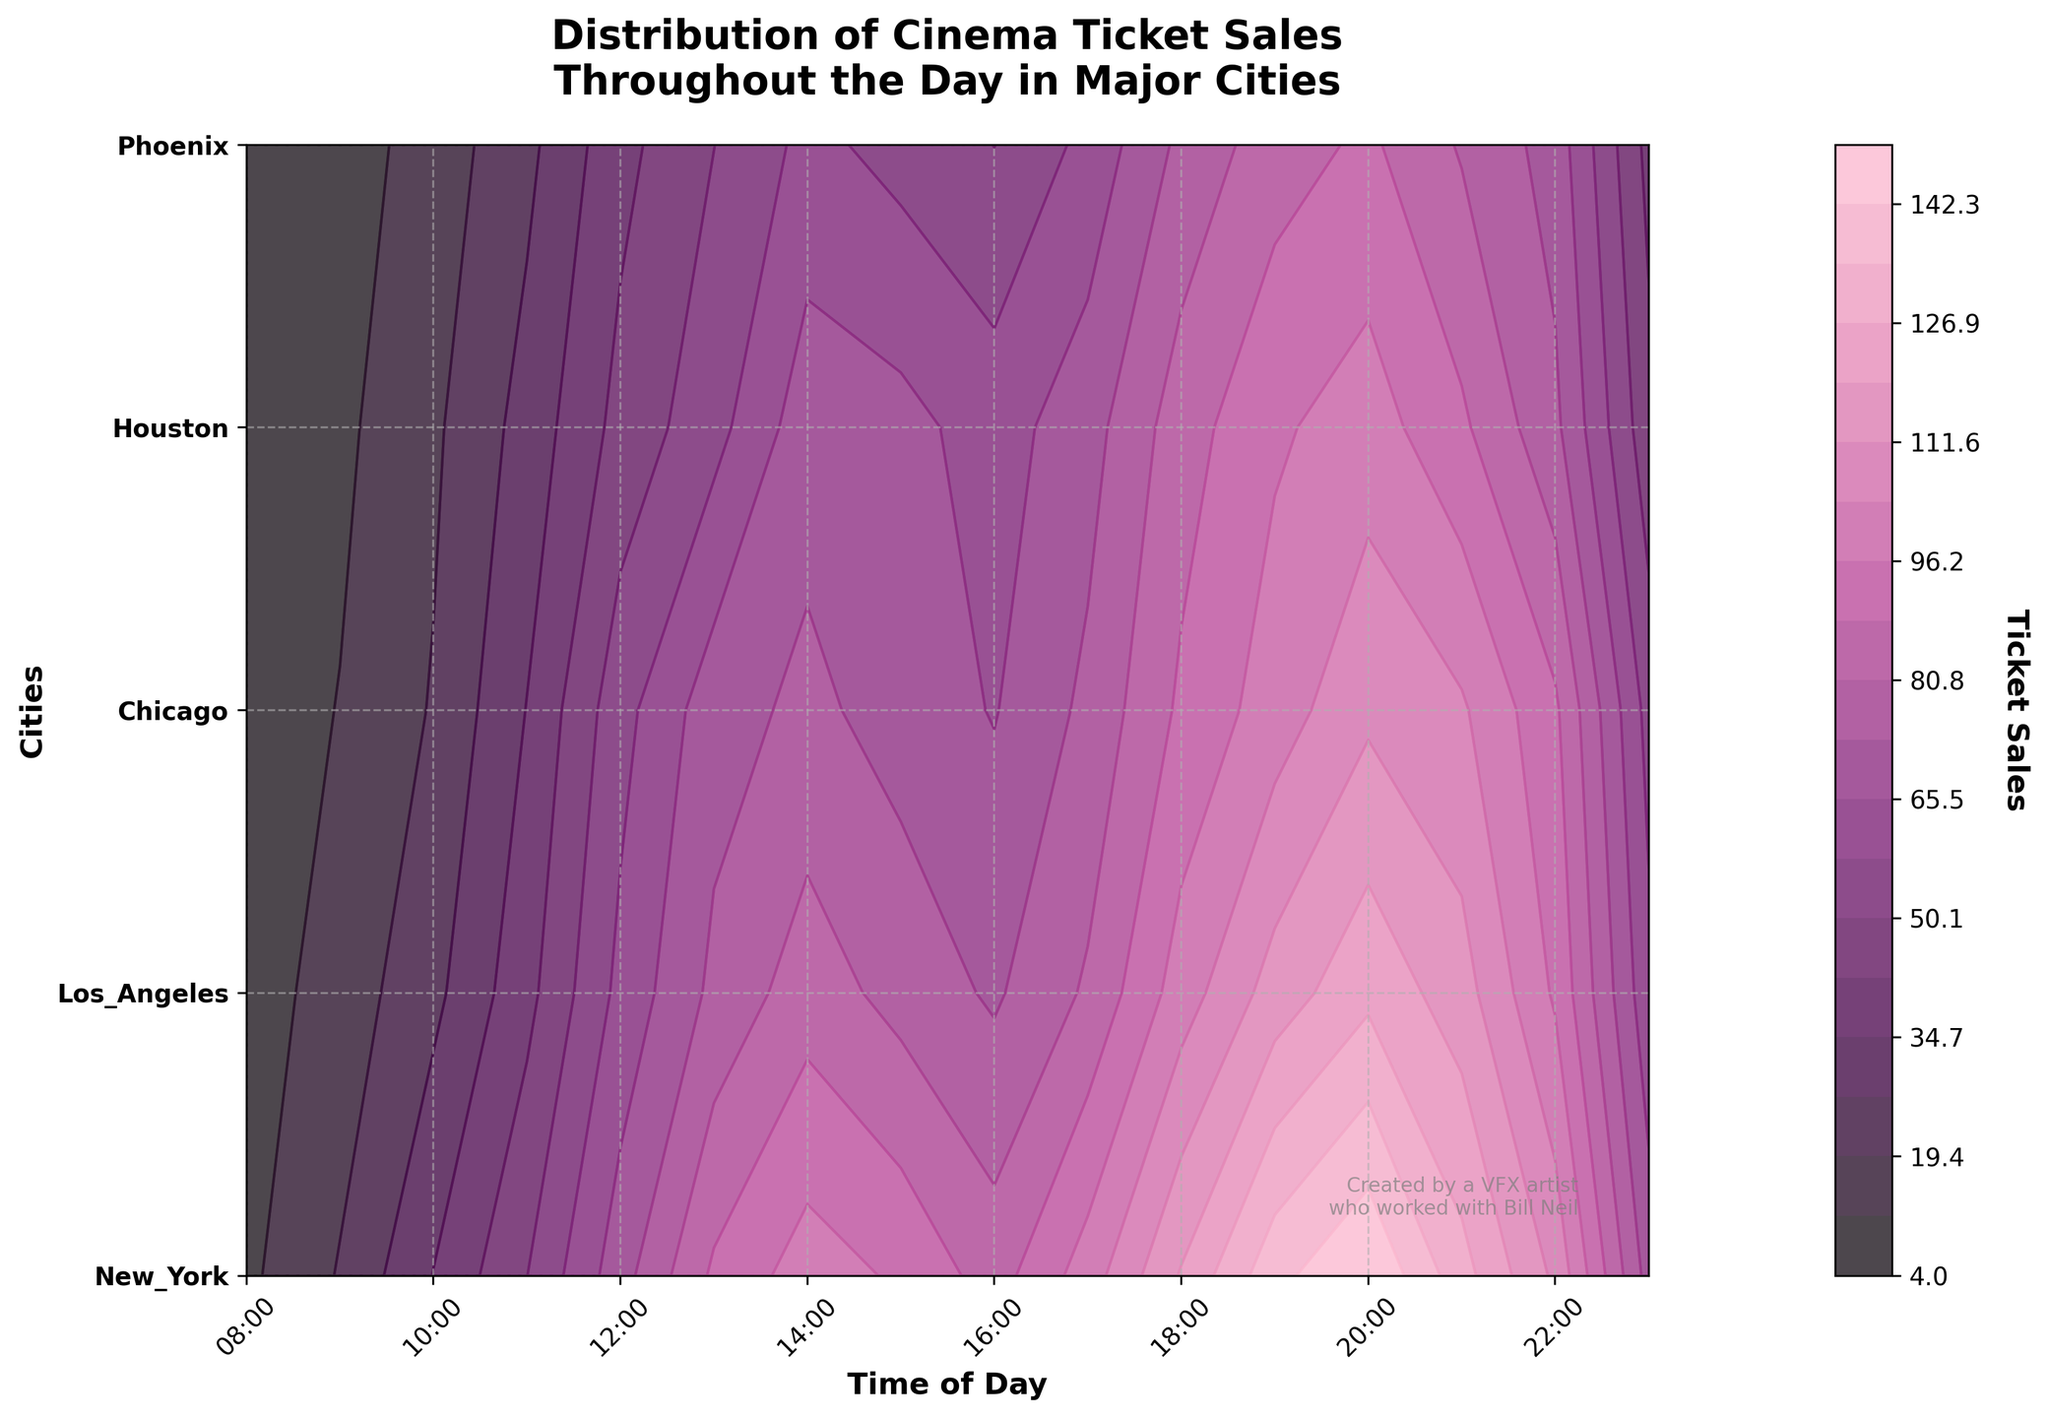What is the title of the plot? The title is located at the top of the plot, and it reads "Distribution of Cinema Ticket Sales Throughout the Day in Major Cities."
Answer: Distribution of Cinema Ticket Sales Throughout the Day in Major Cities Which city has the highest ticket sales at 8 PM? By locating 20:00 on the x-axis and checking the contour levels aligned with the cities on the y-axis, the highest value is seen for New York.
Answer: New York At what time of day does Phoenix reach its peak ticket sales? By following the highest contour level for Phoenix on the plot's y-axis and tracing it back to the x-axis, the peak is at 8 PM.
Answer: 20:00 Compare the ticket sales in New York and Los Angeles at 6 PM. Which city has higher sales? Locate 18:00 on the x-axis and compare the contour levels of New York and Los Angeles on the y-axis. New York has a higher ticket sales value.
Answer: New York What is the range of time during which Chicago's ticket sales are between 50 and 80? Identify the contour levels corresponding to 50 and 80 for Chicago, then trace these levels horizontally to find the corresponding time range on the x-axis. The range is from 11 AM to 8 PM.
Answer: 11:00 to 20:00 During which hours are the ticket sales in Houston always increasing without any decline? Following the contour lines for Houston, observe the time frames where sales only increase. Ticket sales in Houston steadily rise from 8 AM to 1 PM.
Answer: 08:00 to 13:00 How does the distribution of ticket sales in Los Angeles at 3 PM compare to 5 PM? Locate 15:00 and 17:00 on the x-axis, then check the contour levels for Los Angeles on the y-axis. The sales at 3 PM are slightly lower than at 5 PM.
Answer: 3 PM is lower than 5 PM If you were to identify the most optimal time to watch a movie in New York based on ticket sales trends, what time would you pick, assuming you prefer less crowded shows? Locate the times with lower contour levels for New York; early morning (8 AM) or late night (11 PM) have the lower ticket sales.
Answer: 08:00 or 23:00 Which city has the least variability in ticket sales throughout the day? By observing the density and dispersion of contour lines for all cities, Phoenix shows the most consistent and least variability in ticket sales throughout the day.
Answer: Phoenix What are the notable differences in peak ticket sales between New York and Houston? Identify the peak contour levels for both New York and Houston. New York reaches peak sales at 150, whereas Houston peaks at 100, and New York's peaks are more significant compared to Houston.
Answer: New York: 150, Houston: 100 